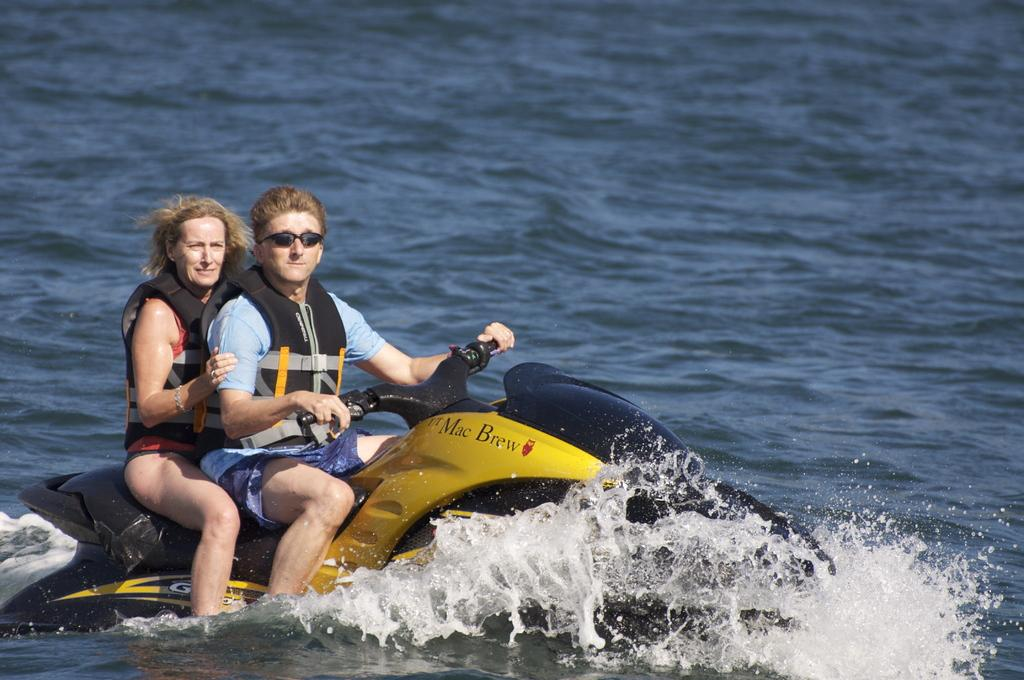<image>
Give a short and clear explanation of the subsequent image. Two people are riding a jet ski with the words Mac Brew on the side. 